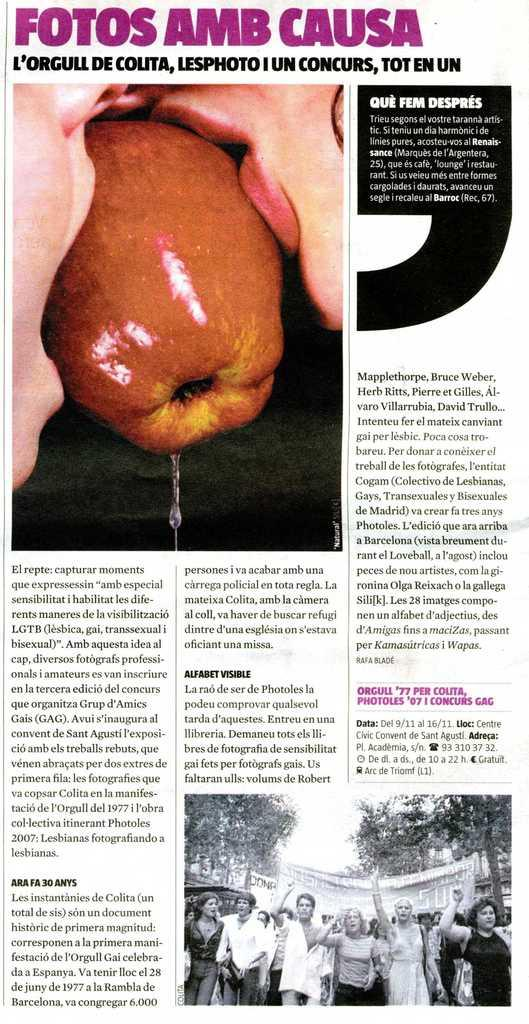<image>
Create a compact narrative representing the image presented. a paper that has the words fotos amb causa on it 